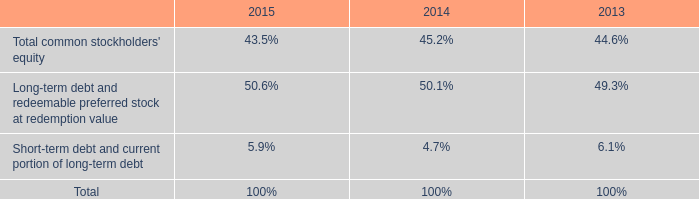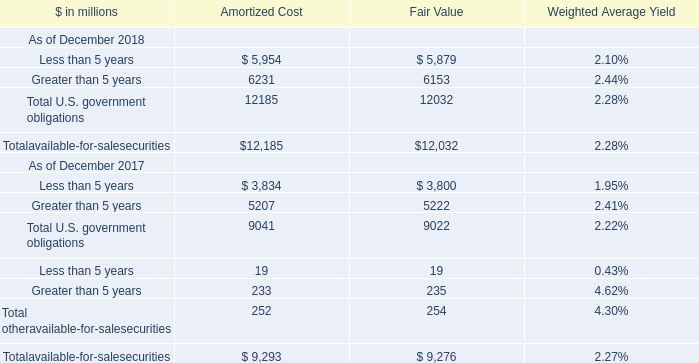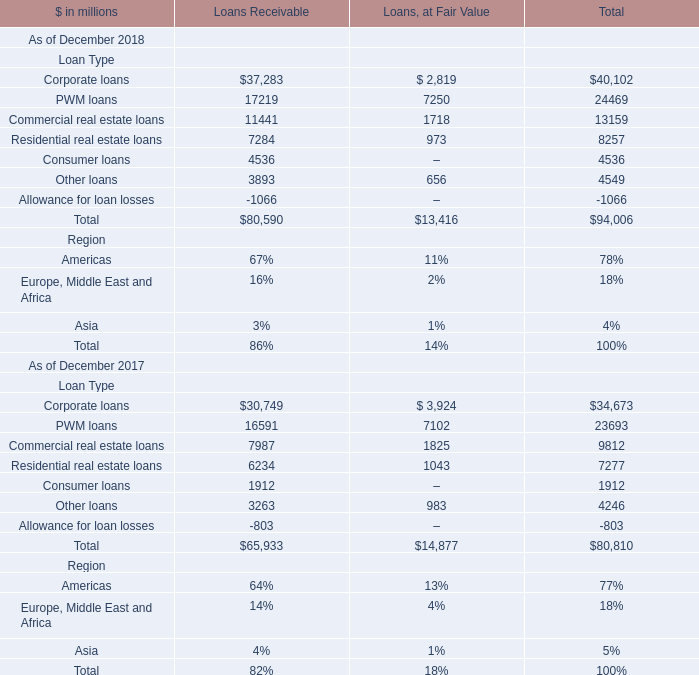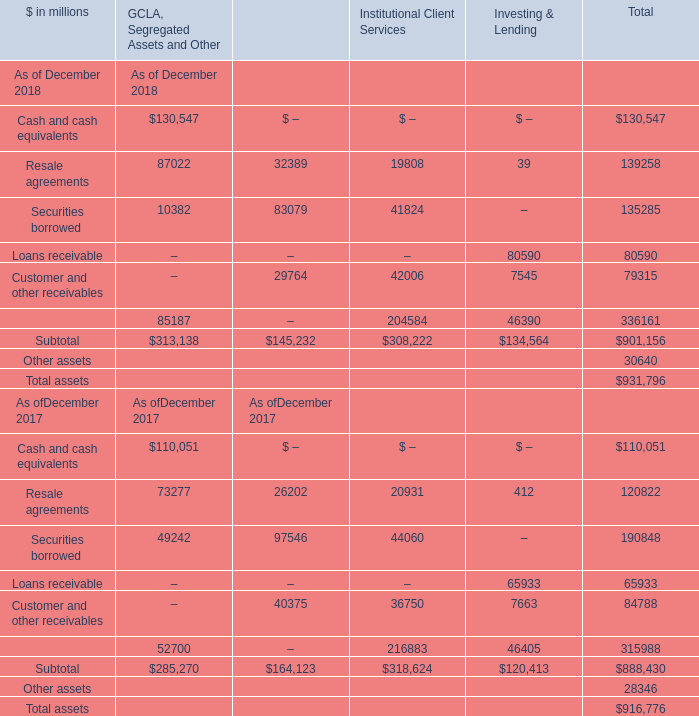What is the percentage of Corporate loans in relation to the total in 2018? 
Computations: (40102 / 94006)
Answer: 0.42659. 